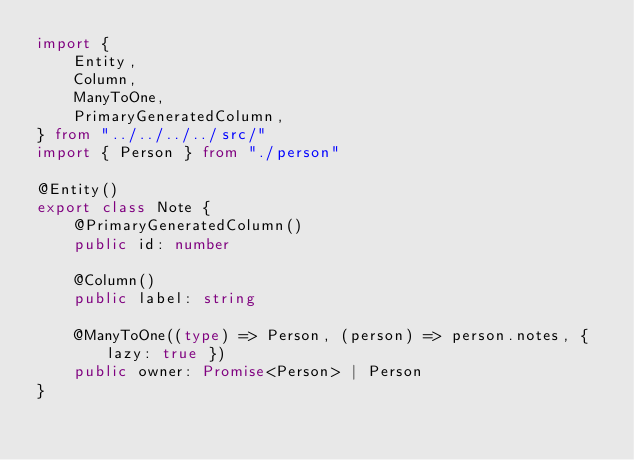<code> <loc_0><loc_0><loc_500><loc_500><_TypeScript_>import {
    Entity,
    Column,
    ManyToOne,
    PrimaryGeneratedColumn,
} from "../../../../src/"
import { Person } from "./person"

@Entity()
export class Note {
    @PrimaryGeneratedColumn()
    public id: number

    @Column()
    public label: string

    @ManyToOne((type) => Person, (person) => person.notes, { lazy: true })
    public owner: Promise<Person> | Person
}
</code> 